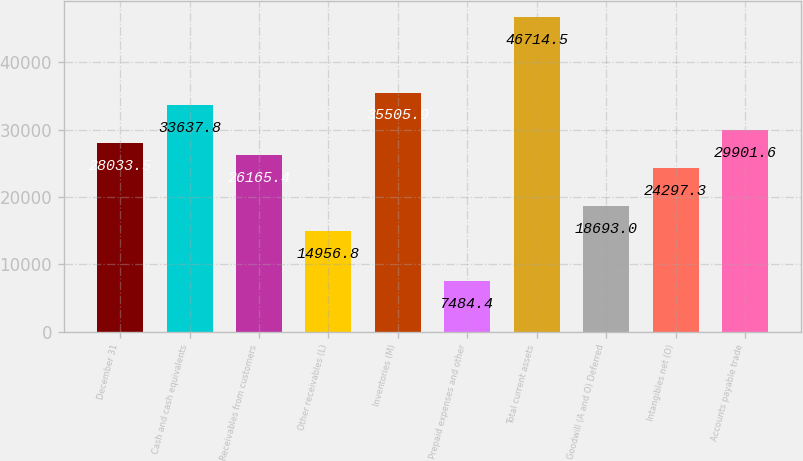<chart> <loc_0><loc_0><loc_500><loc_500><bar_chart><fcel>December 31<fcel>Cash and cash equivalents<fcel>Receivables from customers<fcel>Other receivables (L)<fcel>Inventories (M)<fcel>Prepaid expenses and other<fcel>Total current assets<fcel>Goodwill (A and O) Deferred<fcel>Intangibles net (O)<fcel>Accounts payable trade<nl><fcel>28033.5<fcel>33637.8<fcel>26165.4<fcel>14956.8<fcel>35505.9<fcel>7484.4<fcel>46714.5<fcel>18693<fcel>24297.3<fcel>29901.6<nl></chart> 